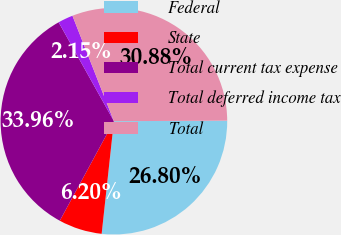Convert chart. <chart><loc_0><loc_0><loc_500><loc_500><pie_chart><fcel>Federal<fcel>State<fcel>Total current tax expense<fcel>Total deferred income tax<fcel>Total<nl><fcel>26.8%<fcel>6.2%<fcel>33.96%<fcel>2.15%<fcel>30.88%<nl></chart> 